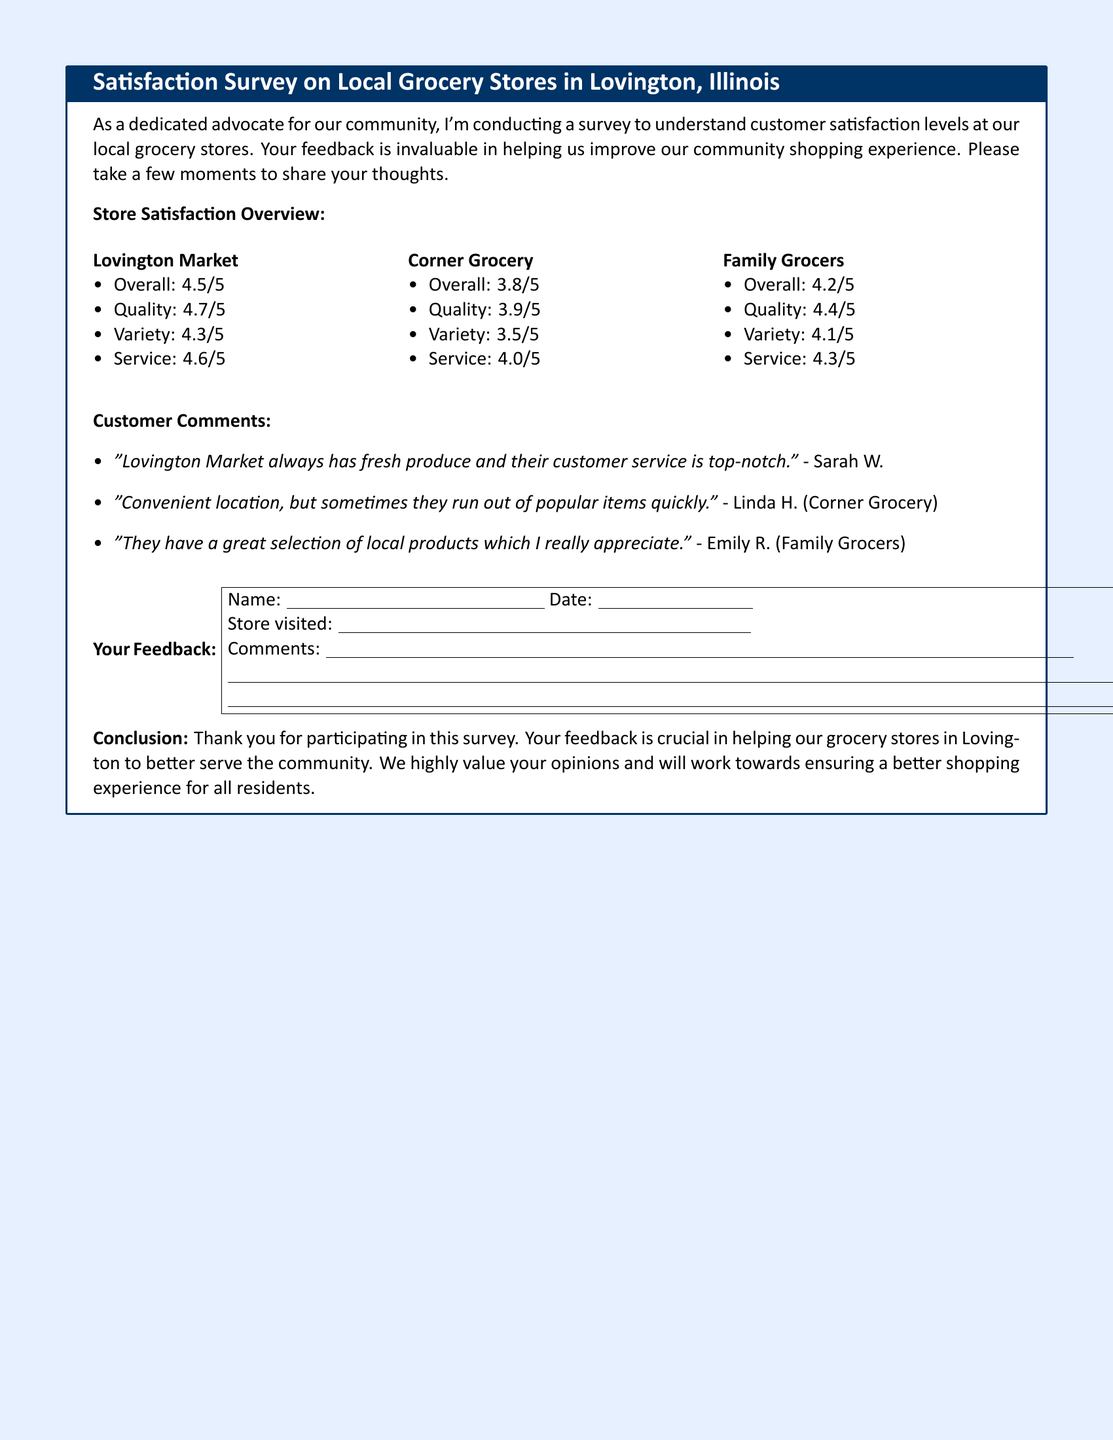What is the overall satisfaction rating for Lovington Market? The overall satisfaction rating is found in the document under Lovington Market.
Answer: 4.5/5 What is the customer service score for Corner Grocery? The customer service score can be located in the Corner Grocery section of the document.
Answer: 4.0/5 Which grocery store has the highest quality rating? The quality ratings are compared under each store's section, showing which one is the highest.
Answer: Lovington Market What comment did Sarah W. provide? Sarah W.'s comment is listed under customer comments in the document.
Answer: "Lovington Market always has fresh produce and their customer service is top-notch." What is the general sentiment of comments regarding product variety? To find out the sentiment of the comments, the document's customer comments section should be analyzed.
Answer: Mostly positive What is the variety rating for Family Grocers? The variety rating can be directly referenced in the Family Grocers section of the survey results.
Answer: 4.1/5 What recommendation is made regarding grocery shopping in Lovington? The conclusion suggests a course of action based on the survey findings.
Answer: Improve grocery stores What is the title of the document? The title is located at the top of the survey form.
Answer: Satisfaction Survey on Local Grocery Stores in Lovington, Illinois How many grocery stores were evaluated in the survey? The number of stores is referenced in the satisfaction overview section of the document.
Answer: 3 